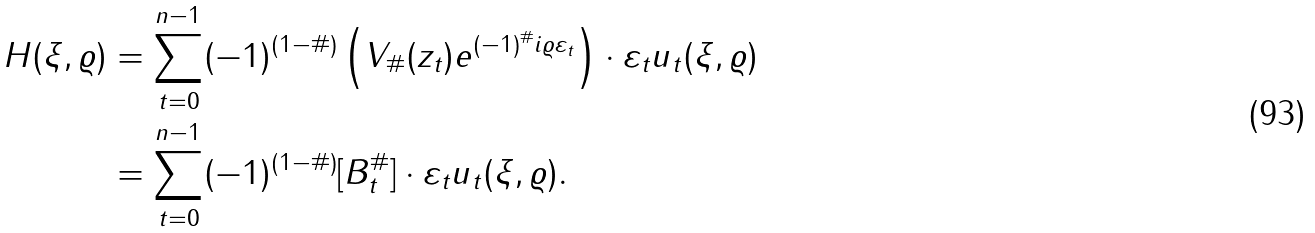Convert formula to latex. <formula><loc_0><loc_0><loc_500><loc_500>H ( \xi , \varrho ) & = \sum _ { t = 0 } ^ { n - 1 } ( - 1 ) ^ { ( 1 - \# ) } \left ( V _ { \# } ( z _ { t } ) e ^ { ( - 1 ) ^ { \# } i \varrho \varepsilon _ { t } } \right ) \cdot \varepsilon _ { t } u _ { t } ( \xi , \varrho ) \\ & = \sum _ { t = 0 } ^ { n - 1 } ( - 1 ) ^ { ( 1 - \# ) } [ { B } _ { t } ^ { \# } ] \cdot \varepsilon _ { t } u _ { t } ( \xi , \varrho ) .</formula> 